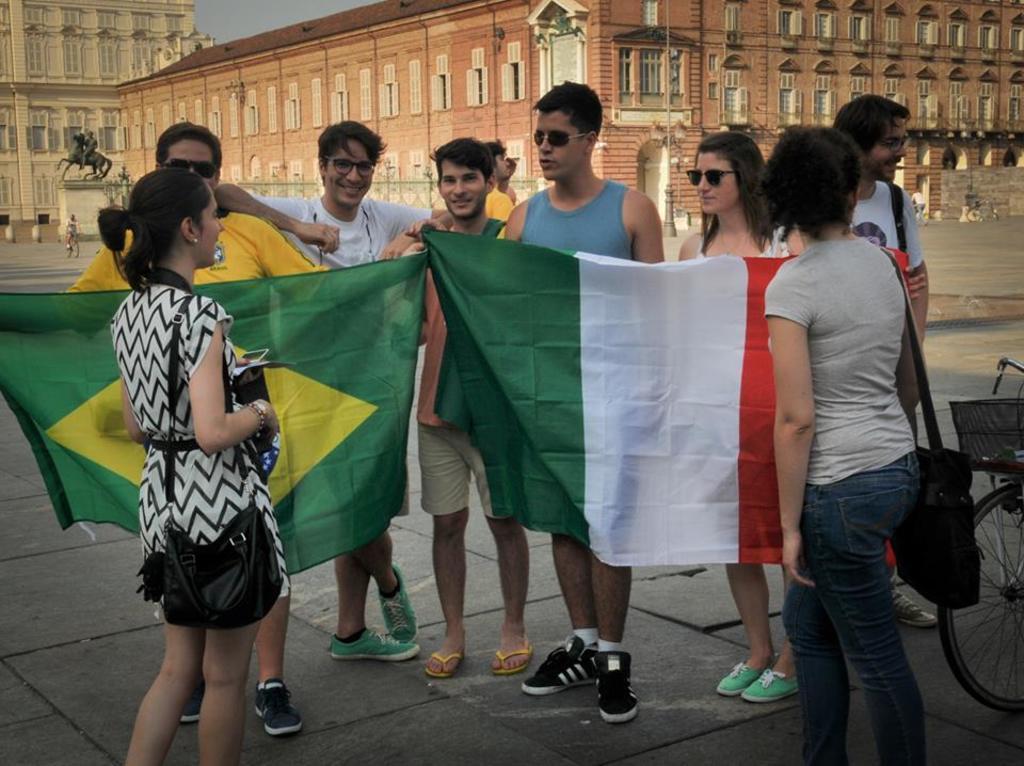How would you summarize this image in a sentence or two? In the foreground of the image there are people holding flags. At the bottom of the image there is floor. To the right side of the image there is a bicycle. In background of the image there are buildings. There is a statue. 